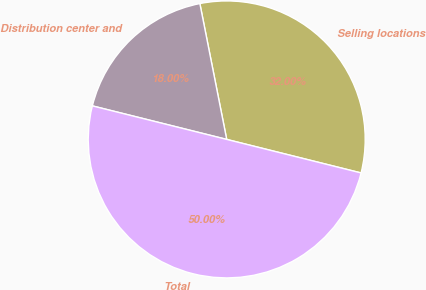Convert chart. <chart><loc_0><loc_0><loc_500><loc_500><pie_chart><fcel>Selling locations<fcel>Distribution center and<fcel>Total<nl><fcel>32.0%<fcel>18.0%<fcel>50.0%<nl></chart> 